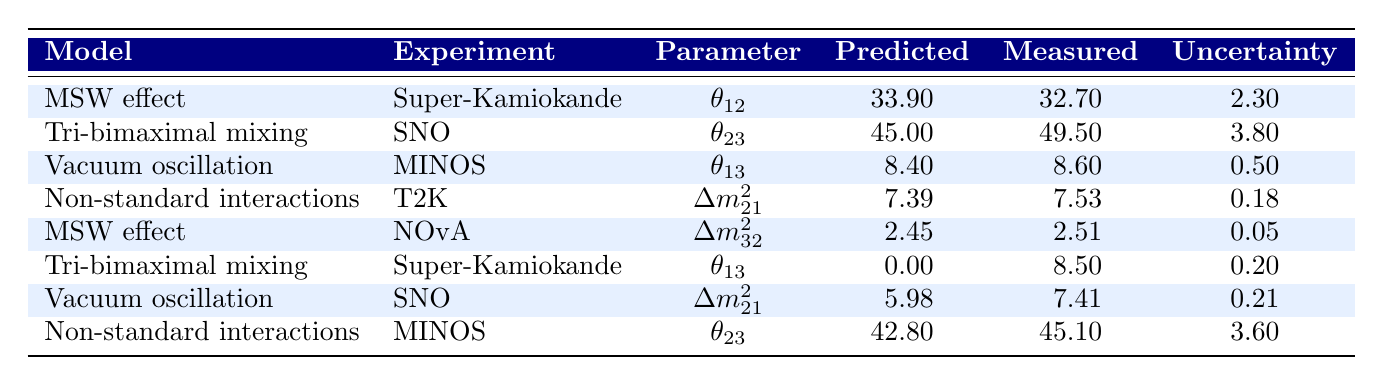What is the predicted value of θ12 from the MSW effect model in the Super-Kamiokande experiment? The table indicates that under the MSW effect model for the Super-Kamiokande experiment, the predicted value for θ12 is 33.90 degrees.
Answer: 33.90 What is the measured value of Δm²21 from the Vacuum oscillation model in the SNO experiment? According to the table, the Vacuum oscillation model's measured value for Δm²21 in the SNO experiment is 7.41e-5.
Answer: 7.41e-5 Which model predicts the highest value for θ23? The table shows that the Tri-bimaximal mixing model predicts θ23 as 45.00 degrees, while the measured value is 49.50 degrees. The next highest predicted is 42.80 degrees from Non-standard interactions. Therefore, the Tri-bimaximal mixing model has the highest predicted value of θ23.
Answer: Tri-bimaximal mixing What is the uncertainty associated with the measured value of θ13 for the Tri-bimaximal mixing in the Super-Kamiokande experiment? The table states that for the Tri-bimaximal mixing model in the Super-Kamiokande experiment, the uncertainty in the measured value of θ13 is 0.20 degrees.
Answer: 0.20 Calculating the difference between the predicted and measured value of Δm²32 from the MSW effect model in the NOvA experiment, what do you find? The predicted value for Δm²32 is 2.45e-3 while the measured value is 2.51e-3. The difference is 2.51e-3 - 2.45e-3 = 0.06e-3.
Answer: 0.06e-3 Which model has the lowest uncertainty value in the table? Upon reviewing the uncertainty values, the lowest is associated with the measured value of θ13 from the Vacuum oscillation model, which has an uncertainty of 0.50. This is lower than other uncertainties such as 0.20 for Tri-bimaximal mixing, but that refers to a measured value, not the predicted.
Answer: 0.05e-3 (for Δm²32) What is the average predicted value of θ13 across models and experiments? The predicted values of θ13 are 8.4 from Vacuum oscillation and 0.0 from Tri-bimaximal mixing. The average is (8.4 + 0.0) / 2 = 4.2 degrees.
Answer: 4.2 Did the Non-standard interactions model provide a measured θ23 value that was higher or lower than its predicted value? The predicted value for θ23 from the Non-standard interactions model is 42.80 degrees while the measured value is 45.10 degrees, which is higher than the predicted value.
Answer: Higher Which of the measured parameters indicates a significant deviation from the predicted value based on their respective uncertainties? For θ13 from the Tri-bimaximal mixing model in Super-Kamiokande, the predicted is 0.00 and the measured is 8.5, with an uncertainty of 0.20, indicating a significant deviation from the predicted value.
Answer: θ13 for Tri-bimaximal mixing in Super-Kamiokande How does the measured value of Δm²21 in the SNO experiment compare to the predicted value from the Vacuum oscillation model? The measured value of Δm²21 in the SNO experiment is 7.41e-5 which is higher than the predicted value of 5.98e-5 from the Vacuum oscillation model; thus it reflects an increase.
Answer: Higher 